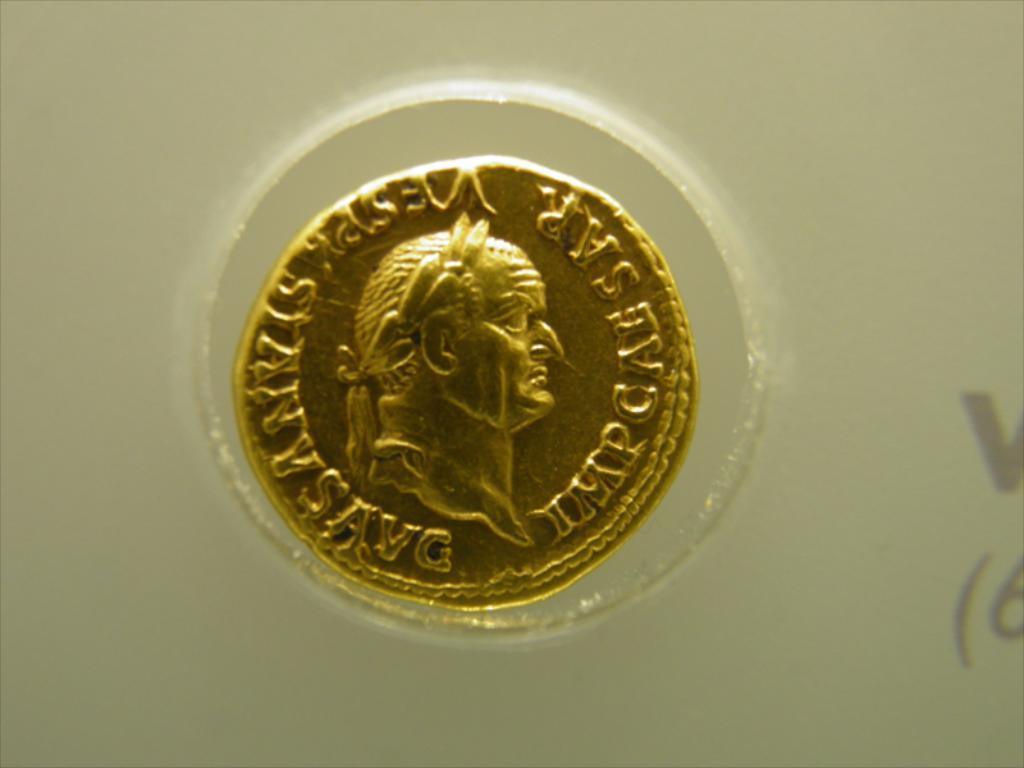<image>
Relay a brief, clear account of the picture shown. The letter M is visible on the side of the coin 